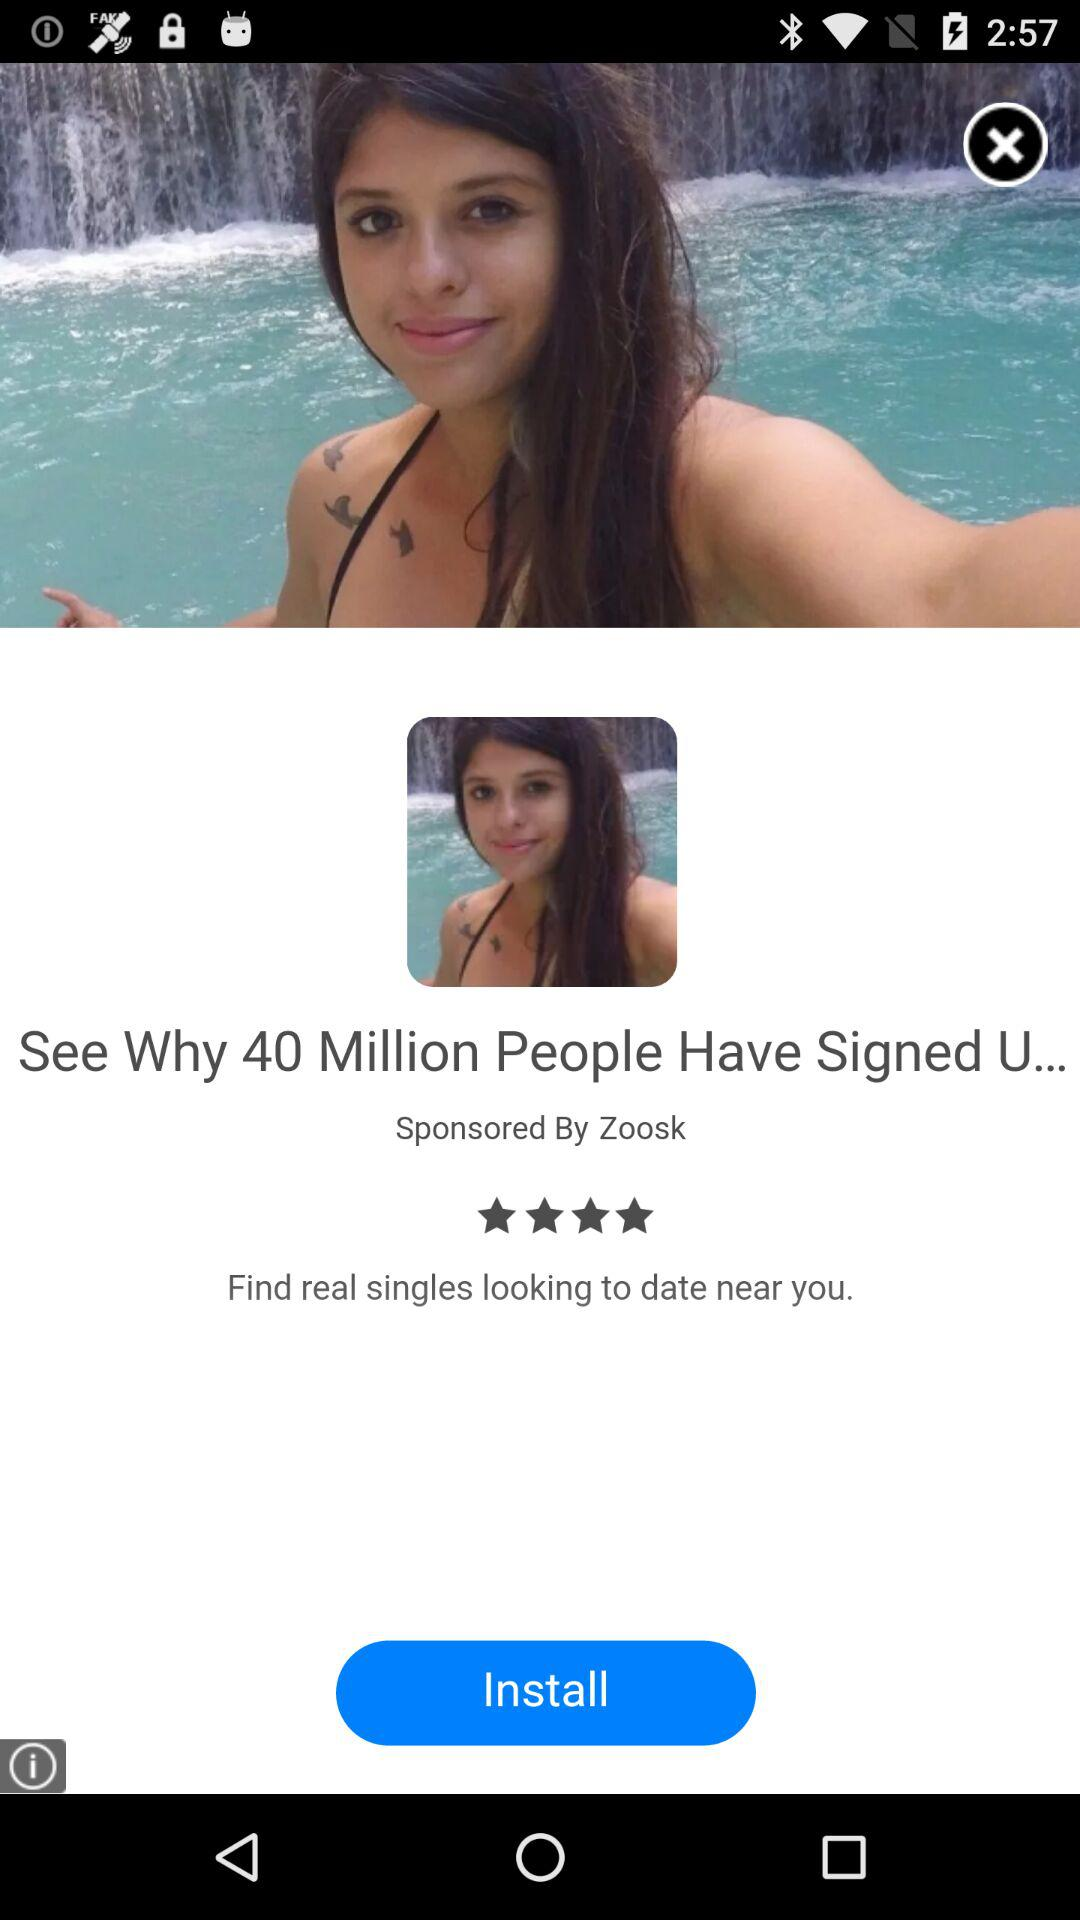By whom is it sponsored? It is sponsored by Zoosk. 